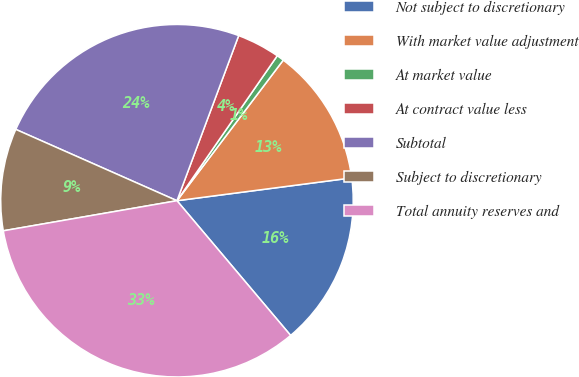Convert chart to OTSL. <chart><loc_0><loc_0><loc_500><loc_500><pie_chart><fcel>Not subject to discretionary<fcel>With market value adjustment<fcel>At market value<fcel>At contract value less<fcel>Subtotal<fcel>Subject to discretionary<fcel>Total annuity reserves and<nl><fcel>15.91%<fcel>12.63%<fcel>0.67%<fcel>3.94%<fcel>24.06%<fcel>9.36%<fcel>33.42%<nl></chart> 